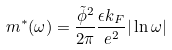Convert formula to latex. <formula><loc_0><loc_0><loc_500><loc_500>m ^ { * } ( \omega ) = \frac { \tilde { \phi } ^ { 2 } } { 2 \pi } \frac { \epsilon k _ { F } } { e ^ { 2 } } | \ln { \omega } |</formula> 